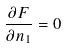<formula> <loc_0><loc_0><loc_500><loc_500>\frac { \partial F } { \partial n _ { 1 } } = 0</formula> 